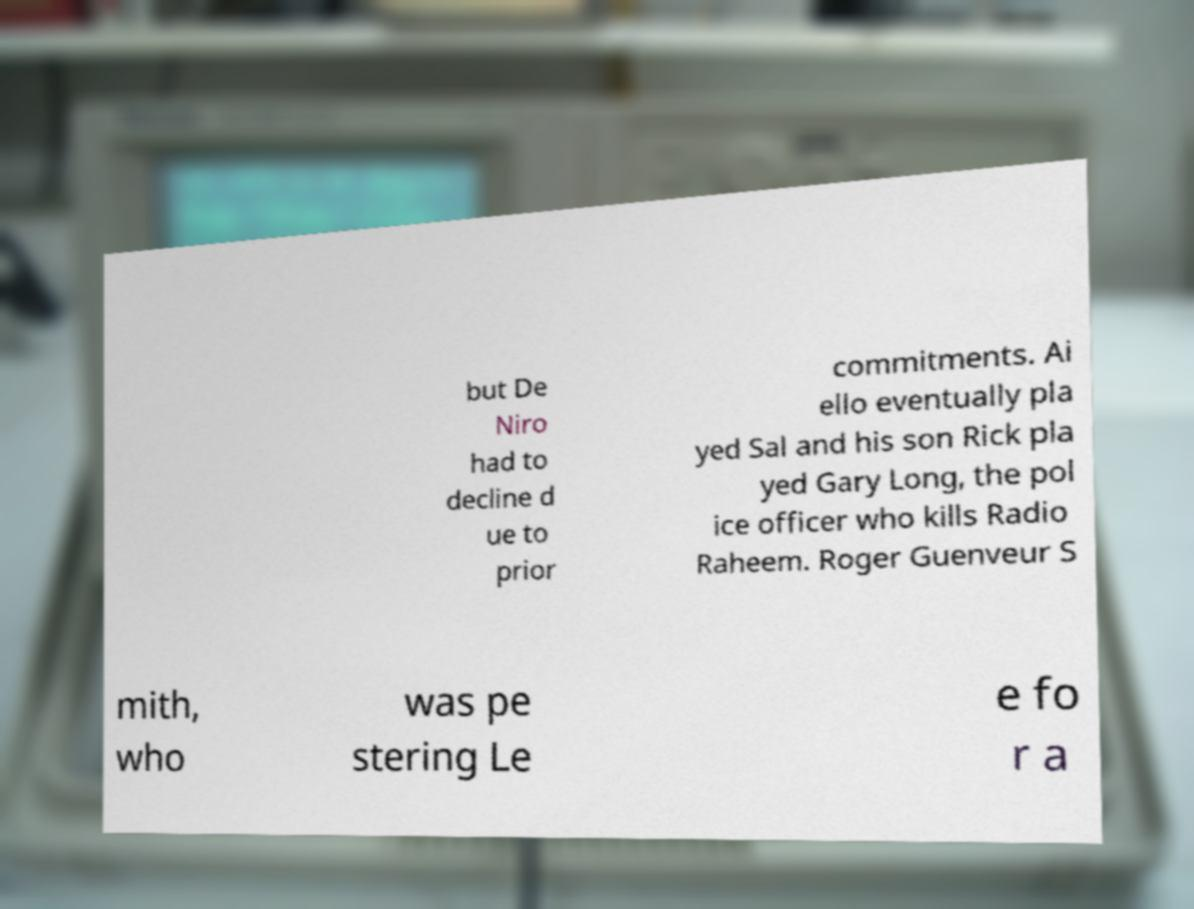For documentation purposes, I need the text within this image transcribed. Could you provide that? but De Niro had to decline d ue to prior commitments. Ai ello eventually pla yed Sal and his son Rick pla yed Gary Long, the pol ice officer who kills Radio Raheem. Roger Guenveur S mith, who was pe stering Le e fo r a 